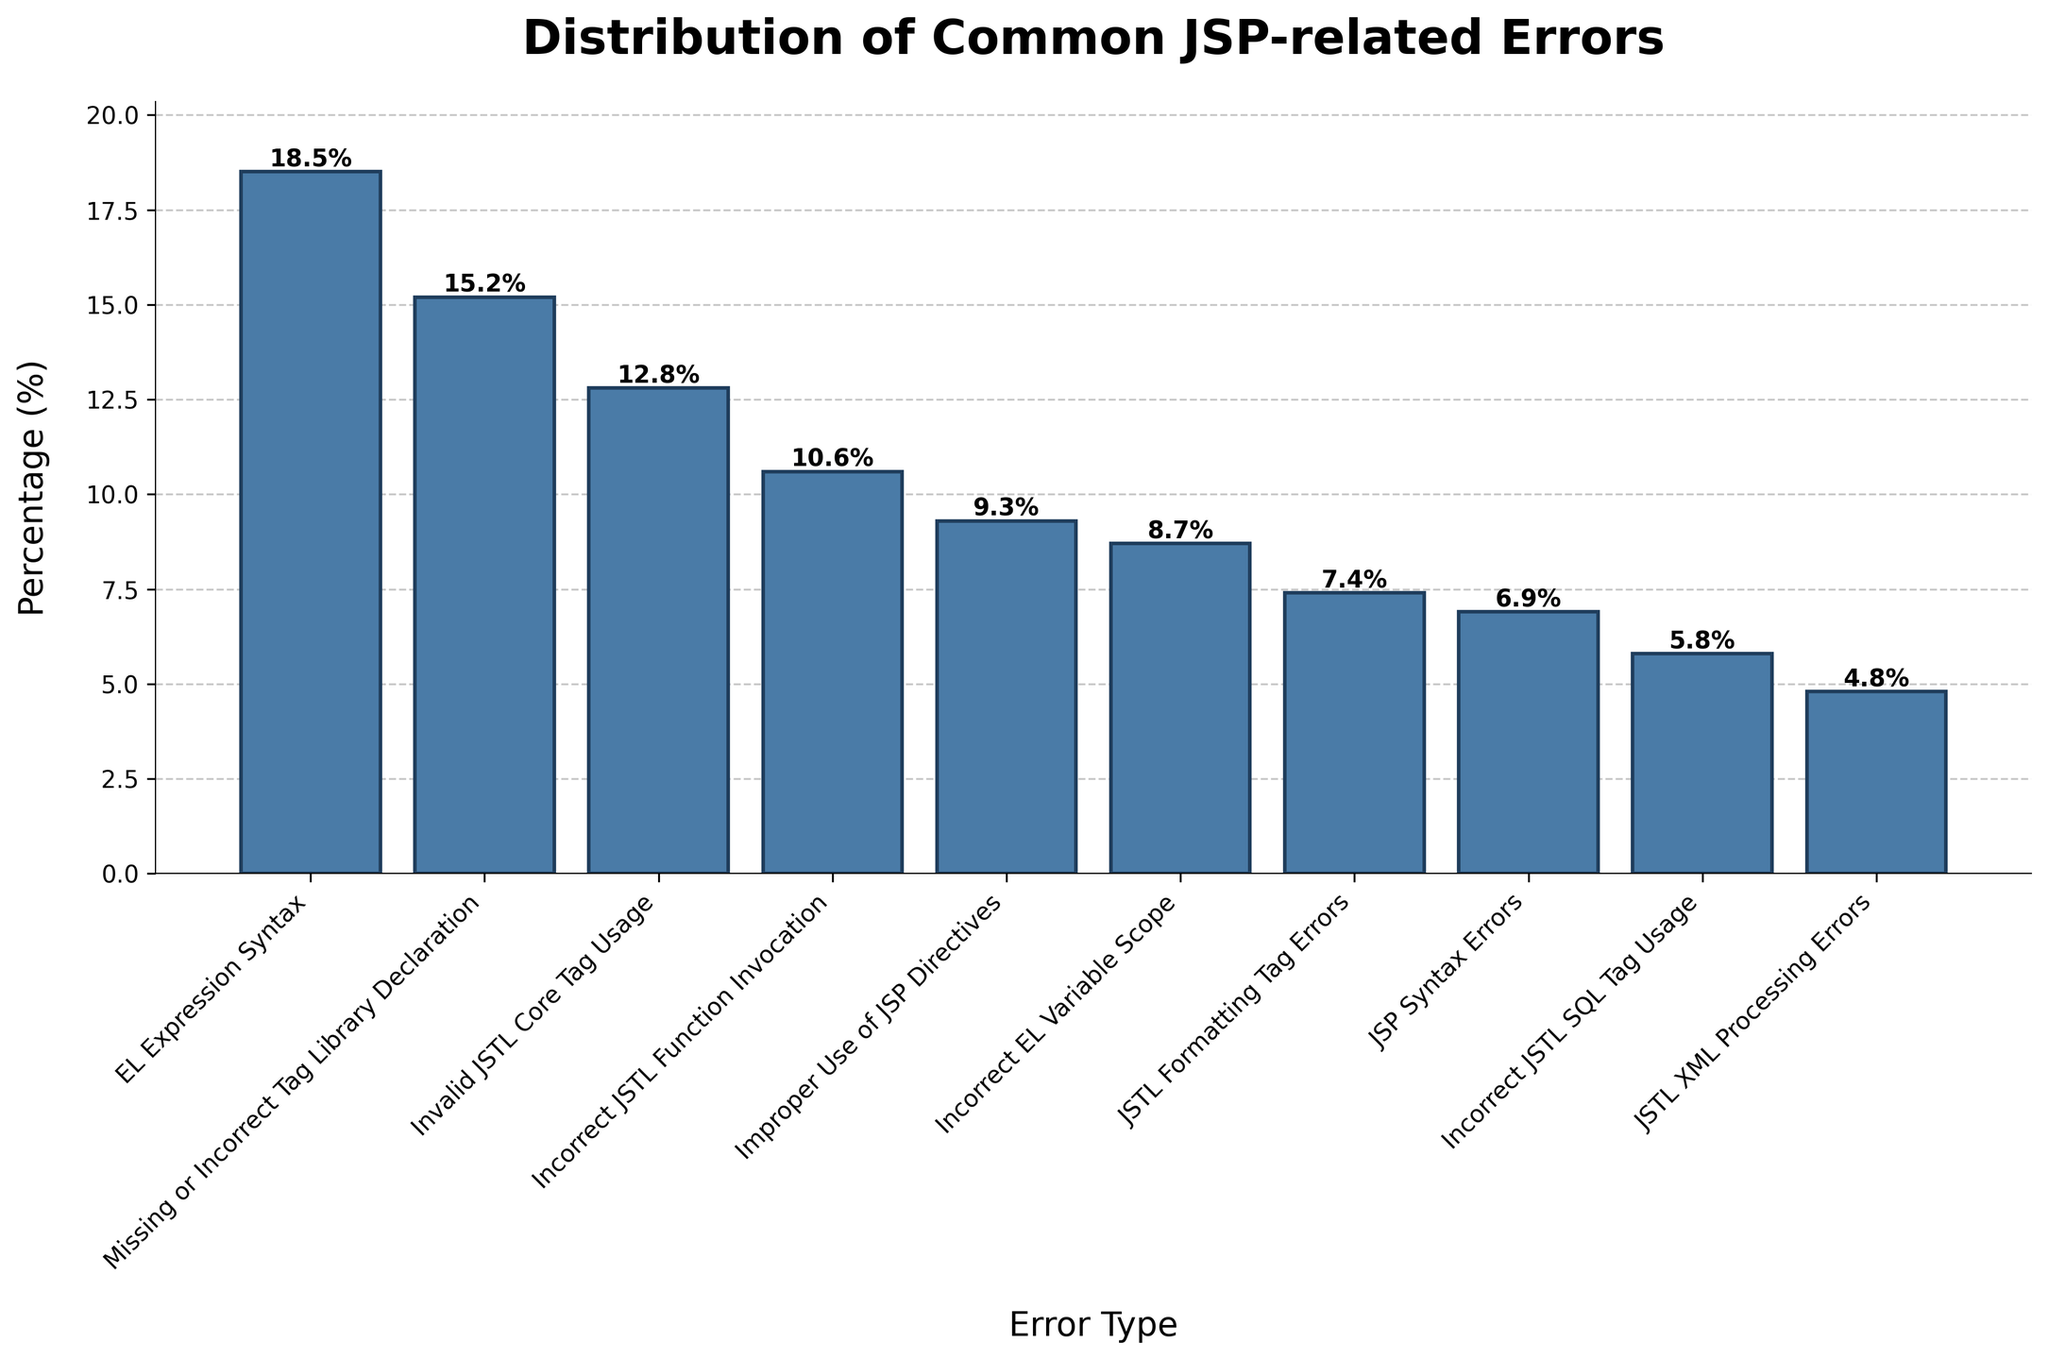What's the most common JSP-related error? The bar representing "EL Expression Syntax" is the highest among all, indicating that it has the highest percentage.
Answer: EL Expression Syntax Which error type is least common? The bar for "JSTL XML Processing Errors" is the shortest among all bars in the plot, indicating it has the lowest percentage.
Answer: JSTL XML Processing Errors What’s the difference in percentage between the most and least common errors? The percentage for "EL Expression Syntax" is 18.5% and for "JSTL XML Processing Errors" is 4.8%. Calculating the difference: 18.5% - 4.8% = 13.7%.
Answer: 13.7% Rank the errors in descending order of their percentages. Arrange the bars from tallest to shortest: EL Expression Syntax (18.5%), Missing or Incorrect Tag Library Declaration (15.2%), Invalid JSTL Core Tag Usage (12.8%), Incorrect JSTL Function Invocation (10.6%), Improper Use of JSP Directives (9.3%), Incorrect EL Variable Scope (8.7%), JSTL Formatting Tag Errors (7.4%), JSP Syntax Errors (6.9%), Incorrect JSTL SQL Tag Usage (5.8%), JSTL XML Processing Errors (4.8%).
Answer: EL Expression Syntax > Missing or Incorrect Tag Library Declaration > Invalid JSTL Core Tag Usage > Incorrect JSTL Function Invocation > Improper Use of JSP Directives > Incorrect EL Variable Scope > JSTL Formatting Tag Errors > JSP Syntax Errors > Incorrect JSTL SQL Tag Usage > JSTL XML Processing Errors How much fewer is the percentage of Incorrect JSTL Function Invocation errors compared to Invalid JSTL Core Tag Usage errors? The percentage for Invalid JSTL Core Tag Usage is 12.8% and for Incorrect JSTL Function Invocation is 10.6%. Calculating the difference: 12.8% - 10.6% = 2.2%.
Answer: 2.2% Which two errors have the closest percentages? The bars for Incorrect JSTL SQL Tag Usage (5.8%) and JSTL XML Processing Errors (4.8%) are visually close in height. Their difference is 1%, which is the smallest difference among all pairs.
Answer: Incorrect JSTL SQL Tag Usage and JSTL XML Processing Errors What is the combined percentage of Improper Use of JSP Directives and JSTL Formatting Tag Errors? Add the percentages for Improper Use of JSP Directives (9.3%) and JSTL Formatting Tag Errors (7.4%): 9.3% + 7.4% = 16.7%.
Answer: 16.7% List all error types that have a percentage greater than 10%. The bars for EL Expression Syntax (18.5%), Missing or Incorrect Tag Library Declaration (15.2%), Invalid JSTL Core Tag Usage (12.8%), and Incorrect JSTL Function Invocation (10.6%) are above 10%.
Answer: EL Expression Syntax, Missing or Incorrect Tag Library Declaration, Invalid JSTL Core Tag Usage, Incorrect JSTL Function Invocation Which error types account for less than 10% each? The bars for Improper Use of JSP Directives (9.3%), Incorrect EL Variable Scope (8.7%), JSTL Formatting Tag Errors (7.4%), JSP Syntax Errors (6.9%), Incorrect JSTL SQL Tag Usage (5.8%), and JSTL XML Processing Errors (4.8%) are below 10%.
Answer: Improper Use of JSP Directives, Incorrect EL Variable Scope, JSTL Formatting Tag Errors, JSP Syntax Errors, Incorrect JSTL SQL Tag Usage, JSTL XML Processing Errors 